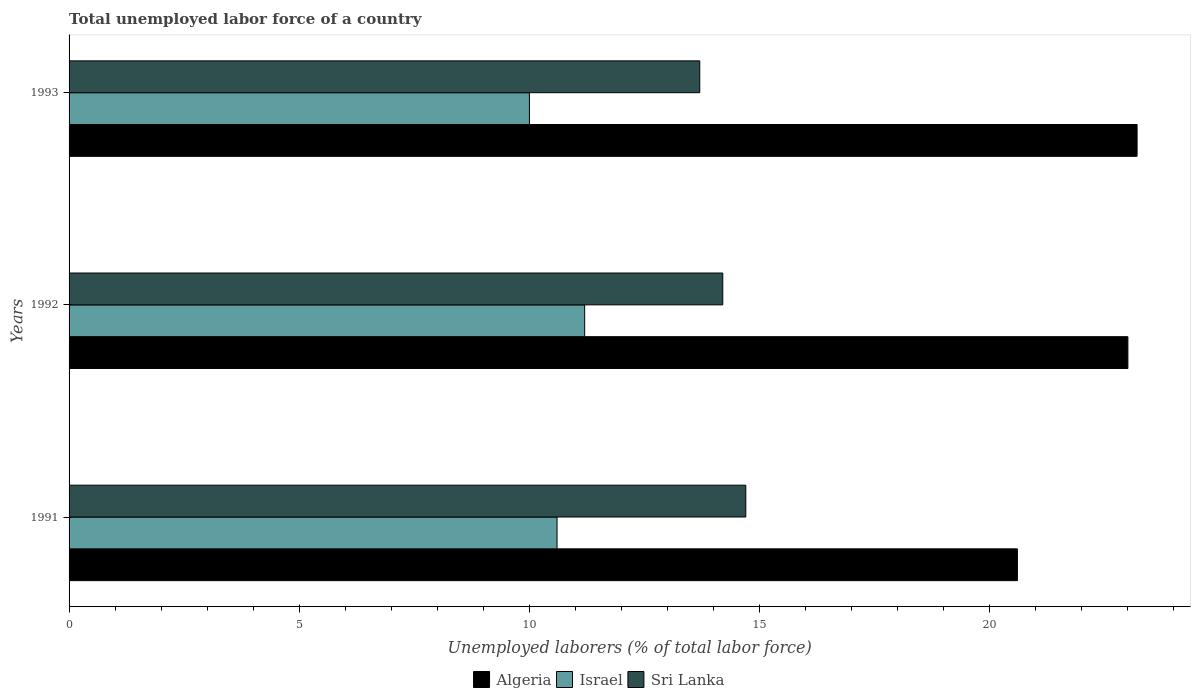How many groups of bars are there?
Your response must be concise. 3. How many bars are there on the 3rd tick from the bottom?
Offer a terse response. 3. What is the label of the 3rd group of bars from the top?
Your response must be concise. 1991. What is the total unemployed labor force in Algeria in 1993?
Make the answer very short. 23.2. Across all years, what is the maximum total unemployed labor force in Algeria?
Keep it short and to the point. 23.2. Across all years, what is the minimum total unemployed labor force in Israel?
Make the answer very short. 10. In which year was the total unemployed labor force in Sri Lanka maximum?
Your answer should be compact. 1991. What is the total total unemployed labor force in Israel in the graph?
Offer a terse response. 31.8. What is the difference between the total unemployed labor force in Algeria in 1991 and that in 1993?
Give a very brief answer. -2.6. What is the difference between the total unemployed labor force in Algeria in 1993 and the total unemployed labor force in Sri Lanka in 1991?
Offer a very short reply. 8.5. What is the average total unemployed labor force in Sri Lanka per year?
Provide a short and direct response. 14.2. In the year 1991, what is the difference between the total unemployed labor force in Sri Lanka and total unemployed labor force in Israel?
Your answer should be very brief. 4.1. What is the ratio of the total unemployed labor force in Algeria in 1991 to that in 1993?
Your answer should be compact. 0.89. What is the difference between the highest and the second highest total unemployed labor force in Algeria?
Provide a short and direct response. 0.2. What does the 1st bar from the top in 1992 represents?
Ensure brevity in your answer.  Sri Lanka. What does the 1st bar from the bottom in 1993 represents?
Offer a terse response. Algeria. Is it the case that in every year, the sum of the total unemployed labor force in Algeria and total unemployed labor force in Israel is greater than the total unemployed labor force in Sri Lanka?
Provide a short and direct response. Yes. How many bars are there?
Keep it short and to the point. 9. How many years are there in the graph?
Ensure brevity in your answer.  3. What is the difference between two consecutive major ticks on the X-axis?
Offer a terse response. 5. Does the graph contain any zero values?
Provide a succinct answer. No. Does the graph contain grids?
Ensure brevity in your answer.  No. How many legend labels are there?
Your answer should be very brief. 3. What is the title of the graph?
Offer a terse response. Total unemployed labor force of a country. What is the label or title of the X-axis?
Your response must be concise. Unemployed laborers (% of total labor force). What is the Unemployed laborers (% of total labor force) of Algeria in 1991?
Offer a very short reply. 20.6. What is the Unemployed laborers (% of total labor force) in Israel in 1991?
Provide a succinct answer. 10.6. What is the Unemployed laborers (% of total labor force) in Sri Lanka in 1991?
Offer a very short reply. 14.7. What is the Unemployed laborers (% of total labor force) of Israel in 1992?
Give a very brief answer. 11.2. What is the Unemployed laborers (% of total labor force) in Sri Lanka in 1992?
Offer a very short reply. 14.2. What is the Unemployed laborers (% of total labor force) of Algeria in 1993?
Your response must be concise. 23.2. What is the Unemployed laborers (% of total labor force) of Sri Lanka in 1993?
Provide a succinct answer. 13.7. Across all years, what is the maximum Unemployed laborers (% of total labor force) in Algeria?
Offer a terse response. 23.2. Across all years, what is the maximum Unemployed laborers (% of total labor force) of Israel?
Provide a short and direct response. 11.2. Across all years, what is the maximum Unemployed laborers (% of total labor force) in Sri Lanka?
Provide a short and direct response. 14.7. Across all years, what is the minimum Unemployed laborers (% of total labor force) of Algeria?
Ensure brevity in your answer.  20.6. Across all years, what is the minimum Unemployed laborers (% of total labor force) of Sri Lanka?
Offer a very short reply. 13.7. What is the total Unemployed laborers (% of total labor force) of Algeria in the graph?
Provide a short and direct response. 66.8. What is the total Unemployed laborers (% of total labor force) in Israel in the graph?
Your answer should be compact. 31.8. What is the total Unemployed laborers (% of total labor force) of Sri Lanka in the graph?
Provide a short and direct response. 42.6. What is the difference between the Unemployed laborers (% of total labor force) of Sri Lanka in 1991 and that in 1993?
Offer a very short reply. 1. What is the difference between the Unemployed laborers (% of total labor force) of Israel in 1992 and that in 1993?
Provide a short and direct response. 1.2. What is the difference between the Unemployed laborers (% of total labor force) of Sri Lanka in 1992 and that in 1993?
Your answer should be very brief. 0.5. What is the difference between the Unemployed laborers (% of total labor force) of Algeria in 1991 and the Unemployed laborers (% of total labor force) of Israel in 1992?
Provide a short and direct response. 9.4. What is the difference between the Unemployed laborers (% of total labor force) of Algeria in 1991 and the Unemployed laborers (% of total labor force) of Sri Lanka in 1993?
Offer a terse response. 6.9. What is the difference between the Unemployed laborers (% of total labor force) of Algeria in 1992 and the Unemployed laborers (% of total labor force) of Sri Lanka in 1993?
Provide a succinct answer. 9.3. What is the average Unemployed laborers (% of total labor force) in Algeria per year?
Offer a terse response. 22.27. What is the average Unemployed laborers (% of total labor force) of Israel per year?
Give a very brief answer. 10.6. In the year 1991, what is the difference between the Unemployed laborers (% of total labor force) of Algeria and Unemployed laborers (% of total labor force) of Sri Lanka?
Give a very brief answer. 5.9. In the year 1992, what is the difference between the Unemployed laborers (% of total labor force) of Algeria and Unemployed laborers (% of total labor force) of Sri Lanka?
Keep it short and to the point. 8.8. In the year 1992, what is the difference between the Unemployed laborers (% of total labor force) in Israel and Unemployed laborers (% of total labor force) in Sri Lanka?
Make the answer very short. -3. In the year 1993, what is the difference between the Unemployed laborers (% of total labor force) in Algeria and Unemployed laborers (% of total labor force) in Israel?
Give a very brief answer. 13.2. In the year 1993, what is the difference between the Unemployed laborers (% of total labor force) of Algeria and Unemployed laborers (% of total labor force) of Sri Lanka?
Your answer should be very brief. 9.5. What is the ratio of the Unemployed laborers (% of total labor force) of Algeria in 1991 to that in 1992?
Give a very brief answer. 0.9. What is the ratio of the Unemployed laborers (% of total labor force) of Israel in 1991 to that in 1992?
Offer a very short reply. 0.95. What is the ratio of the Unemployed laborers (% of total labor force) of Sri Lanka in 1991 to that in 1992?
Ensure brevity in your answer.  1.04. What is the ratio of the Unemployed laborers (% of total labor force) in Algeria in 1991 to that in 1993?
Provide a succinct answer. 0.89. What is the ratio of the Unemployed laborers (% of total labor force) in Israel in 1991 to that in 1993?
Your answer should be very brief. 1.06. What is the ratio of the Unemployed laborers (% of total labor force) of Sri Lanka in 1991 to that in 1993?
Your response must be concise. 1.07. What is the ratio of the Unemployed laborers (% of total labor force) of Israel in 1992 to that in 1993?
Provide a short and direct response. 1.12. What is the ratio of the Unemployed laborers (% of total labor force) of Sri Lanka in 1992 to that in 1993?
Keep it short and to the point. 1.04. What is the difference between the highest and the second highest Unemployed laborers (% of total labor force) in Algeria?
Offer a very short reply. 0.2. What is the difference between the highest and the second highest Unemployed laborers (% of total labor force) of Israel?
Keep it short and to the point. 0.6. What is the difference between the highest and the lowest Unemployed laborers (% of total labor force) in Sri Lanka?
Give a very brief answer. 1. 